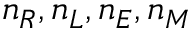Convert formula to latex. <formula><loc_0><loc_0><loc_500><loc_500>n _ { R } , n _ { L } , n _ { E } , n _ { M }</formula> 